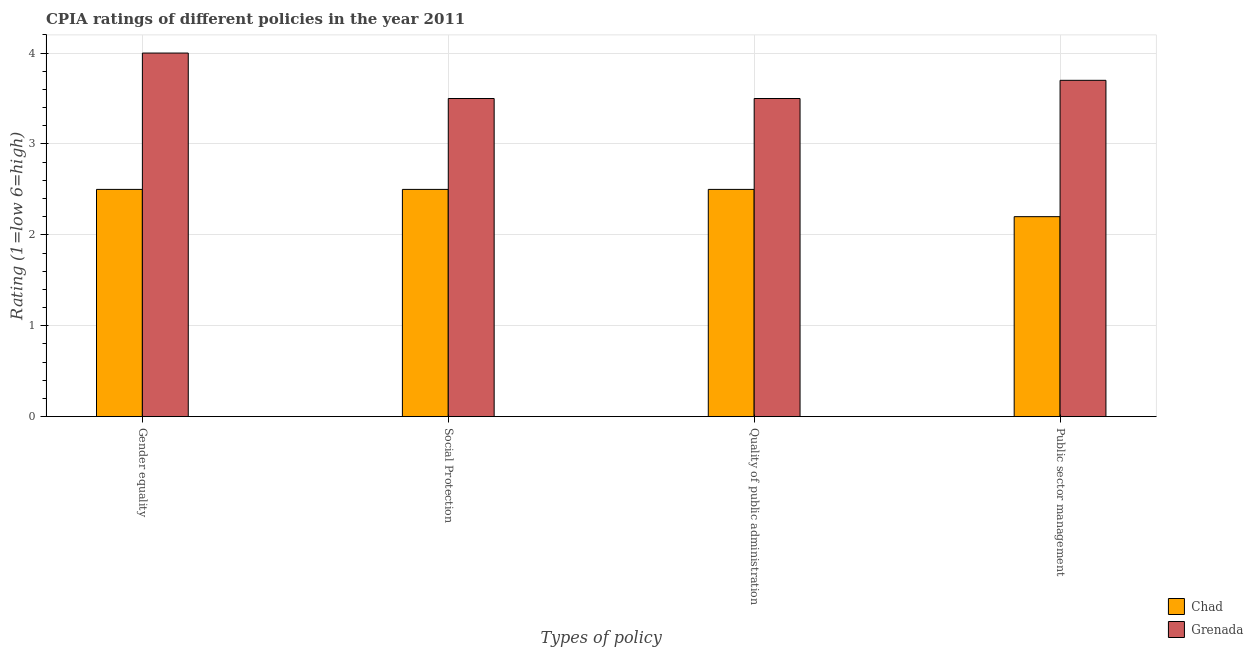How many different coloured bars are there?
Provide a succinct answer. 2. Are the number of bars per tick equal to the number of legend labels?
Ensure brevity in your answer.  Yes. Are the number of bars on each tick of the X-axis equal?
Provide a short and direct response. Yes. How many bars are there on the 2nd tick from the left?
Give a very brief answer. 2. How many bars are there on the 1st tick from the right?
Give a very brief answer. 2. What is the label of the 1st group of bars from the left?
Make the answer very short. Gender equality. In which country was the cpia rating of gender equality maximum?
Offer a very short reply. Grenada. In which country was the cpia rating of quality of public administration minimum?
Keep it short and to the point. Chad. What is the difference between the cpia rating of public sector management in Grenada and that in Chad?
Provide a succinct answer. 1.5. In how many countries, is the cpia rating of public sector management greater than 0.2 ?
Give a very brief answer. 2. What is the ratio of the cpia rating of quality of public administration in Chad to that in Grenada?
Provide a succinct answer. 0.71. Is the cpia rating of public sector management in Grenada less than that in Chad?
Give a very brief answer. No. What is the difference between the highest and the second highest cpia rating of quality of public administration?
Your answer should be compact. 1. What is the difference between the highest and the lowest cpia rating of social protection?
Ensure brevity in your answer.  1. What does the 2nd bar from the left in Public sector management represents?
Keep it short and to the point. Grenada. What does the 2nd bar from the right in Social Protection represents?
Offer a very short reply. Chad. Is it the case that in every country, the sum of the cpia rating of gender equality and cpia rating of social protection is greater than the cpia rating of quality of public administration?
Offer a very short reply. Yes. How many bars are there?
Your response must be concise. 8. Are all the bars in the graph horizontal?
Ensure brevity in your answer.  No. What is the difference between two consecutive major ticks on the Y-axis?
Offer a very short reply. 1. Are the values on the major ticks of Y-axis written in scientific E-notation?
Ensure brevity in your answer.  No. Does the graph contain grids?
Give a very brief answer. Yes. Where does the legend appear in the graph?
Your answer should be very brief. Bottom right. How many legend labels are there?
Offer a terse response. 2. How are the legend labels stacked?
Keep it short and to the point. Vertical. What is the title of the graph?
Your answer should be compact. CPIA ratings of different policies in the year 2011. What is the label or title of the X-axis?
Provide a succinct answer. Types of policy. What is the Rating (1=low 6=high) in Chad in Gender equality?
Offer a terse response. 2.5. What is the Rating (1=low 6=high) of Grenada in Social Protection?
Provide a succinct answer. 3.5. What is the Rating (1=low 6=high) in Grenada in Quality of public administration?
Provide a succinct answer. 3.5. Across all Types of policy, what is the minimum Rating (1=low 6=high) in Chad?
Offer a very short reply. 2.2. What is the total Rating (1=low 6=high) in Chad in the graph?
Your answer should be very brief. 9.7. What is the total Rating (1=low 6=high) of Grenada in the graph?
Provide a succinct answer. 14.7. What is the difference between the Rating (1=low 6=high) of Chad in Gender equality and that in Social Protection?
Your answer should be compact. 0. What is the difference between the Rating (1=low 6=high) of Grenada in Gender equality and that in Quality of public administration?
Make the answer very short. 0.5. What is the difference between the Rating (1=low 6=high) in Chad in Gender equality and that in Public sector management?
Offer a terse response. 0.3. What is the difference between the Rating (1=low 6=high) of Grenada in Gender equality and that in Public sector management?
Provide a succinct answer. 0.3. What is the difference between the Rating (1=low 6=high) of Grenada in Quality of public administration and that in Public sector management?
Your answer should be very brief. -0.2. What is the difference between the Rating (1=low 6=high) of Chad in Gender equality and the Rating (1=low 6=high) of Grenada in Social Protection?
Give a very brief answer. -1. What is the difference between the Rating (1=low 6=high) in Chad in Social Protection and the Rating (1=low 6=high) in Grenada in Quality of public administration?
Make the answer very short. -1. What is the average Rating (1=low 6=high) of Chad per Types of policy?
Offer a very short reply. 2.42. What is the average Rating (1=low 6=high) in Grenada per Types of policy?
Offer a very short reply. 3.67. What is the difference between the Rating (1=low 6=high) of Chad and Rating (1=low 6=high) of Grenada in Gender equality?
Your answer should be very brief. -1.5. What is the difference between the Rating (1=low 6=high) of Chad and Rating (1=low 6=high) of Grenada in Quality of public administration?
Give a very brief answer. -1. What is the ratio of the Rating (1=low 6=high) in Chad in Gender equality to that in Social Protection?
Provide a succinct answer. 1. What is the ratio of the Rating (1=low 6=high) in Grenada in Gender equality to that in Social Protection?
Ensure brevity in your answer.  1.14. What is the ratio of the Rating (1=low 6=high) of Chad in Gender equality to that in Quality of public administration?
Keep it short and to the point. 1. What is the ratio of the Rating (1=low 6=high) in Grenada in Gender equality to that in Quality of public administration?
Provide a succinct answer. 1.14. What is the ratio of the Rating (1=low 6=high) of Chad in Gender equality to that in Public sector management?
Offer a terse response. 1.14. What is the ratio of the Rating (1=low 6=high) of Grenada in Gender equality to that in Public sector management?
Keep it short and to the point. 1.08. What is the ratio of the Rating (1=low 6=high) of Chad in Social Protection to that in Public sector management?
Make the answer very short. 1.14. What is the ratio of the Rating (1=low 6=high) in Grenada in Social Protection to that in Public sector management?
Offer a very short reply. 0.95. What is the ratio of the Rating (1=low 6=high) in Chad in Quality of public administration to that in Public sector management?
Provide a short and direct response. 1.14. What is the ratio of the Rating (1=low 6=high) of Grenada in Quality of public administration to that in Public sector management?
Your response must be concise. 0.95. What is the difference between the highest and the lowest Rating (1=low 6=high) of Chad?
Keep it short and to the point. 0.3. 